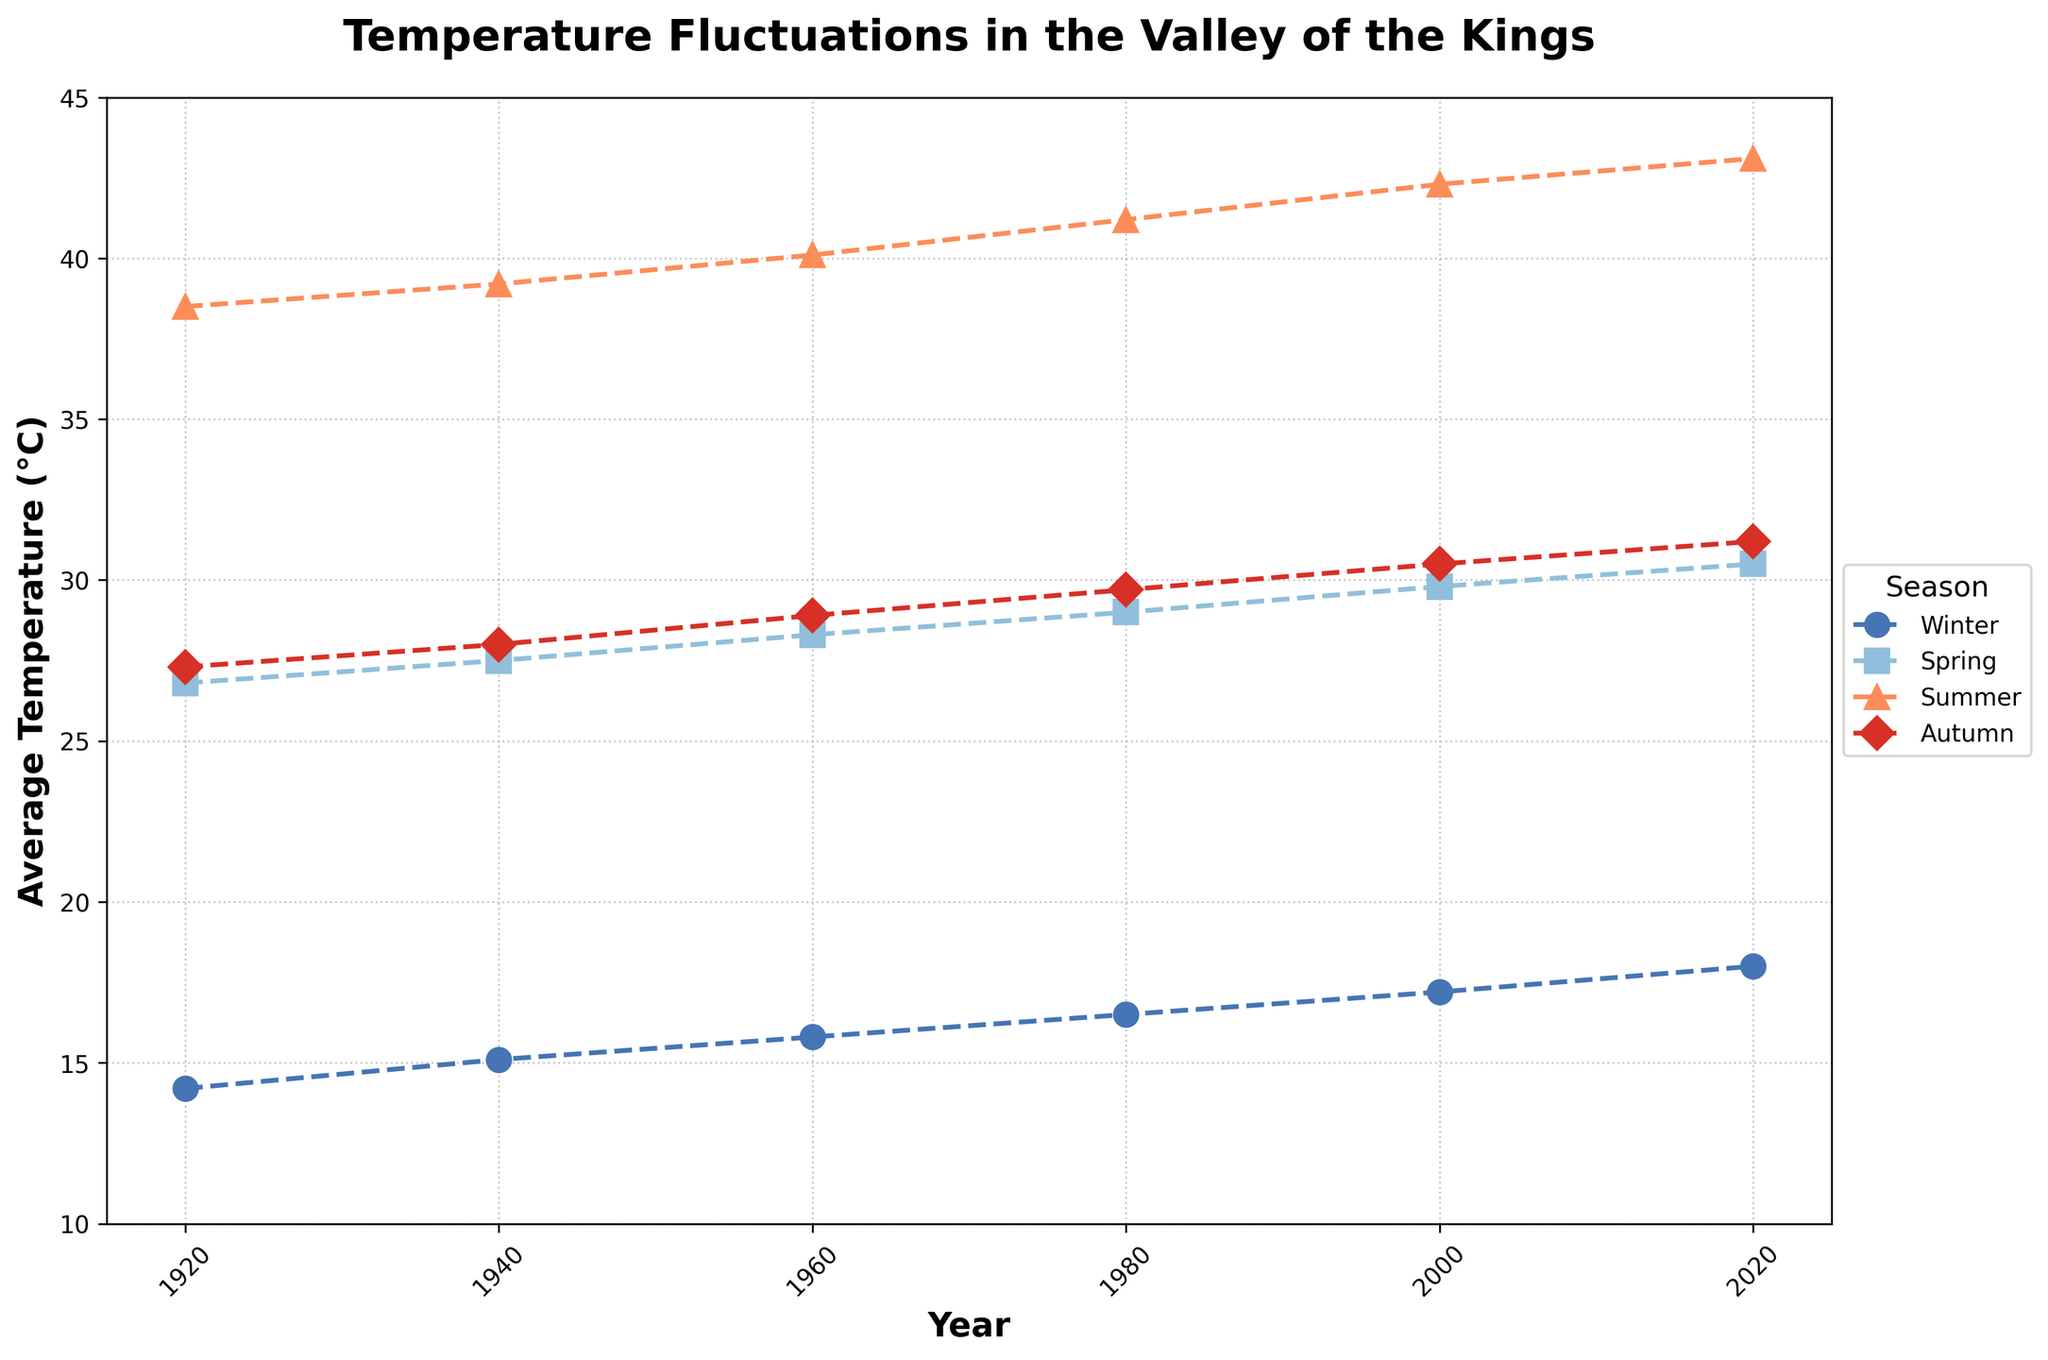What's the average temperature in the year 1920? Look at the temperatures for all the seasons in 1920: Winter: 14.2, Spring: 26.8, Summer: 38.5, Autumn: 27.3. To find the average, sum all these values and divide by 4. (14.2 + 26.8 + 38.5 + 27.3) / 4 = 26.7
Answer: 26.7 Which season showed the greatest increase in average temperature from 1920 to 2020? Compare the temperatures in 1920 and 2020 for each season: Winter (18.0 - 14.2 = 3.8), Spring (30.5 - 26.8 = 3.7), Summer (43.1 - 38.5 = 4.6), Autumn (31.2 - 27.3 = 3.9). The greatest increase is in Summer, with 4.6°C.
Answer: Summer Which season had the most stable temperature pattern from 1920 to 2020? Stability can be assessed by examining the seasonal lines on the plot and noting which one has the smallest range of fluctuations. Winter varies from 14.2 to 18.0 (3.8), Spring from 26.8 to 30.5 (3.7), Summer from 38.5 to 43.1 (4.6), and Autumn from 27.3 to 31.2 (3.9). Spring shows the least variation with a range of 3.7.
Answer: Spring Is the temperature trend over the 100 years uniformly increasing for all seasons? Observe the plots for each season to see if there is a consistent upward trend. For Winter, Spring, Summer, and Autumn, the temperatures show a steady increase over time without any major downward deviations.
Answer: Yes What is the difference in average temperature between Summer and Winter in the year 1980? From the plot, find the average temperatures in 1980: Summer is 41.2°C and Winter is 16.5°C. The difference is 41.2 - 16.5 = 24.7
Answer: 24.7 Which season has the highest average temperature in the year 2000? Review the temperatures for the year 2000: Winter (17.2), Spring (29.8), Summer (42.3), and Autumn (30.5). Summer has the highest value.
Answer: Summer What is the range of Autumn temperatures over this period? Determine the highest and lowest Autumn temperatures: the highest is 31.2°C in 2020 and lowest is 27.3°C in 1920. The range is 31.2 - 27.3 = 3.9.
Answer: 3.9 How does the average temperature in Winter 1940 compare to Winter 1960? Look at Winter temperatures for 1940 (15.1°C) and 1960 (15.8°C). The temperature in 1960 is higher by 15.8 - 15.1 = 0.7°C.
Answer: Winter 1960 is higher by 0.7°C Which year shows the smallest difference in temperature between Summer and Autumn? Calculate the difference for each year: 1920 (38.5 - 27.3 = 11.2), 1940 (39.2 - 28.0 = 11.2), 1960 (40.1 - 28.9 = 11.2), 1980 (41.2 - 29.7 = 11.5), 2000 (42.3 - 30.5 = 11.8), 2020 (43.1 - 31.2 = 11.9). The smallest difference, occurring in the years 1920, 1940, and 1960, is 11.2°C.
Answer: 1920, 1940, 1960 